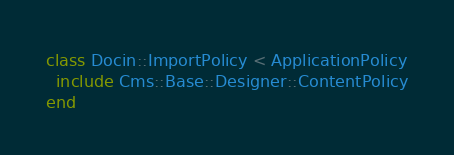<code> <loc_0><loc_0><loc_500><loc_500><_Ruby_>class Docin::ImportPolicy < ApplicationPolicy
  include Cms::Base::Designer::ContentPolicy
end
</code> 